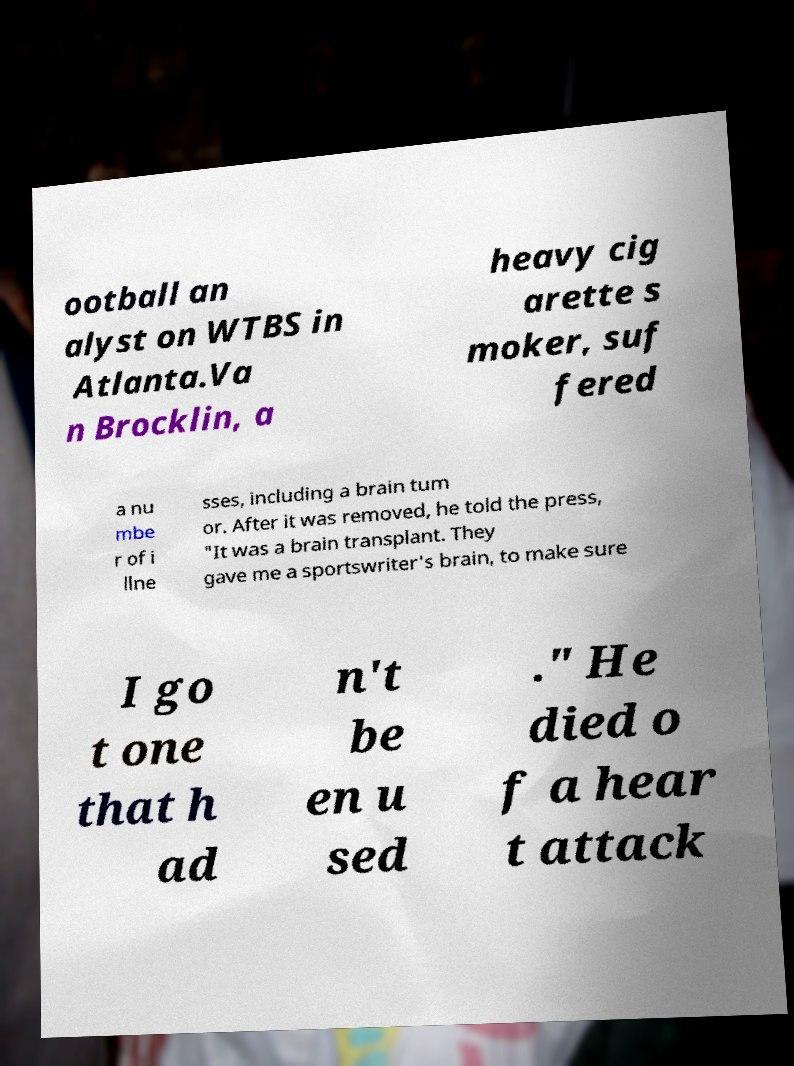Could you extract and type out the text from this image? ootball an alyst on WTBS in Atlanta.Va n Brocklin, a heavy cig arette s moker, suf fered a nu mbe r of i llne sses, including a brain tum or. After it was removed, he told the press, "It was a brain transplant. They gave me a sportswriter's brain, to make sure I go t one that h ad n't be en u sed ." He died o f a hear t attack 